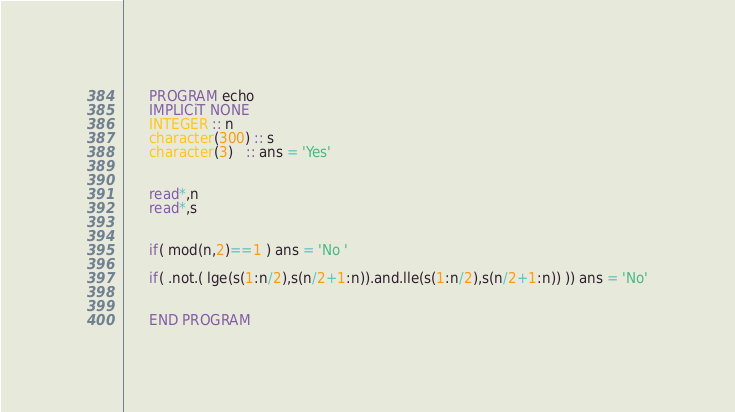Convert code to text. <code><loc_0><loc_0><loc_500><loc_500><_FORTRAN_>      PROGRAM echo
      IMPLICiT NONE
      INTEGER :: n
      character(300) :: s
      character(3)   :: ans = 'Yes'

      
      read*,n
      read*,s
      
      
      if( mod(n,2)==1 ) ans = 'No '
      
      if( .not.( lge(s(1:n/2),s(n/2+1:n)).and.lle(s(1:n/2),s(n/2+1:n)) )) ans = 'No'
      
      
      END PROGRAM</code> 